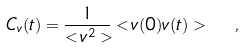Convert formula to latex. <formula><loc_0><loc_0><loc_500><loc_500>C _ { v } ( t ) = \frac { 1 } { < v ^ { 2 } > } < v ( 0 ) v ( t ) > \ \ ,</formula> 